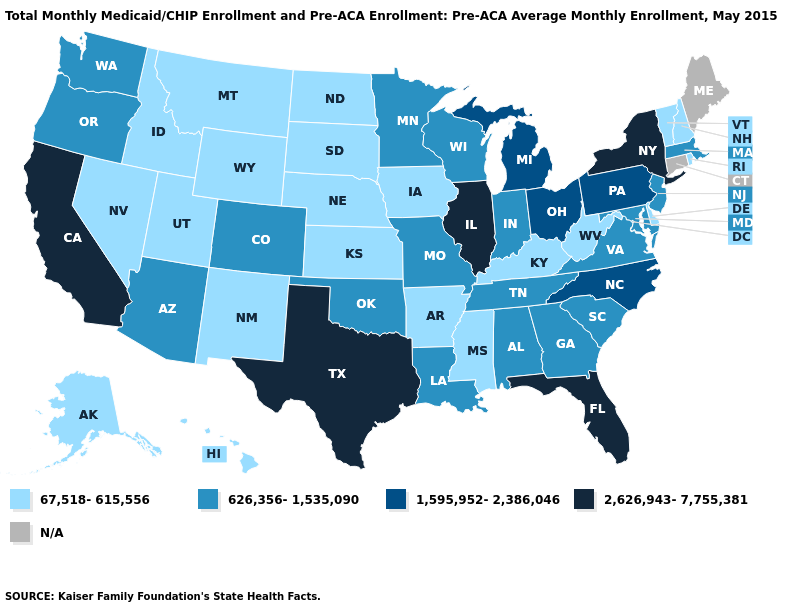Name the states that have a value in the range 1,595,952-2,386,046?
Keep it brief. Michigan, North Carolina, Ohio, Pennsylvania. What is the lowest value in states that border Vermont?
Write a very short answer. 67,518-615,556. What is the highest value in states that border Oregon?
Quick response, please. 2,626,943-7,755,381. Among the states that border Virginia , does North Carolina have the highest value?
Quick response, please. Yes. Is the legend a continuous bar?
Give a very brief answer. No. Which states hav the highest value in the South?
Write a very short answer. Florida, Texas. What is the value of Connecticut?
Concise answer only. N/A. What is the value of New Hampshire?
Write a very short answer. 67,518-615,556. How many symbols are there in the legend?
Short answer required. 5. What is the value of New York?
Keep it brief. 2,626,943-7,755,381. Does Illinois have the highest value in the MidWest?
Keep it brief. Yes. Does New York have the highest value in the Northeast?
Concise answer only. Yes. Name the states that have a value in the range 67,518-615,556?
Be succinct. Alaska, Arkansas, Delaware, Hawaii, Idaho, Iowa, Kansas, Kentucky, Mississippi, Montana, Nebraska, Nevada, New Hampshire, New Mexico, North Dakota, Rhode Island, South Dakota, Utah, Vermont, West Virginia, Wyoming. Name the states that have a value in the range 626,356-1,535,090?
Concise answer only. Alabama, Arizona, Colorado, Georgia, Indiana, Louisiana, Maryland, Massachusetts, Minnesota, Missouri, New Jersey, Oklahoma, Oregon, South Carolina, Tennessee, Virginia, Washington, Wisconsin. 